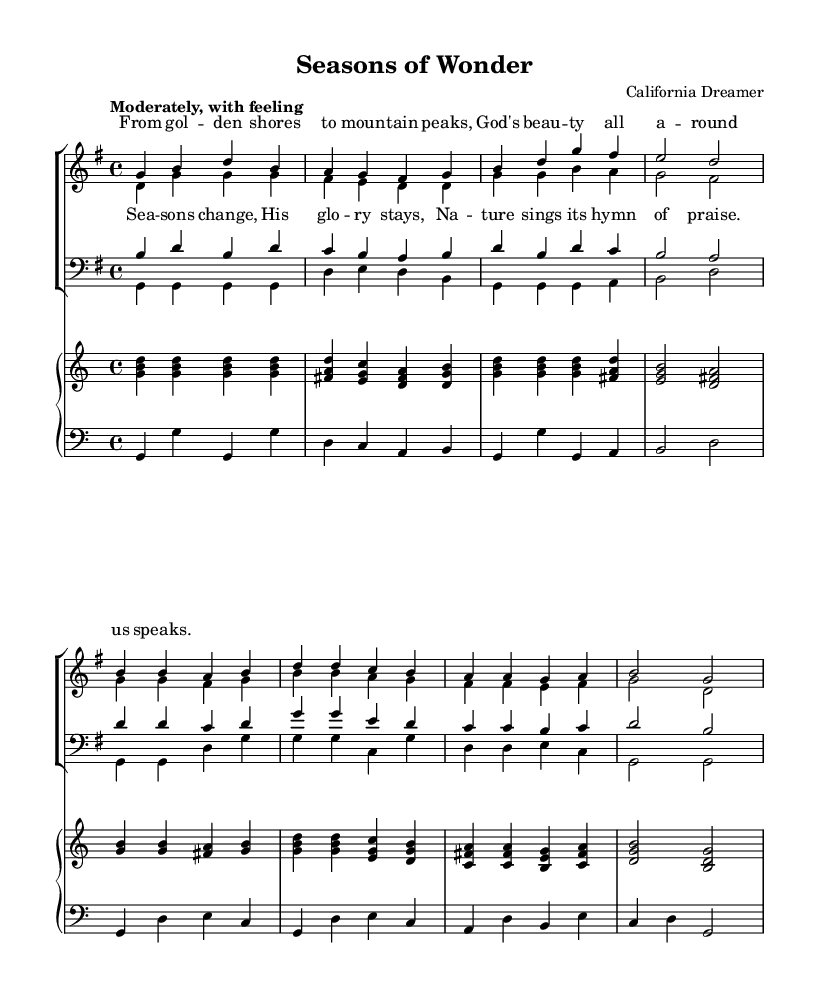What is the key signature of this music? The key signature is G major, which has one sharp (F#). This can be identified by the key signature notation at the beginning of the staff.
Answer: G major What is the time signature of this music? The time signature is 4/4, indicated by the fraction at the beginning of the piece. This means there are four beats in every measure and the quarter note gets one beat.
Answer: 4/4 What is the tempo marking for this piece? The tempo marking is "Moderately, with feeling," which indicates the speed and expression intended by the composer. It reflects a moderate pace.
Answer: Moderately, with feeling How many verses are set to music in this piece? There are two verses presented in the score, one for the soprano/alto part and another for the tenor/bass part. Each section is structured with similar musical phrases, indicating the format of verses.
Answer: Two verses What lyrical theme does the chorus emphasize? The chorus lyrics emphasize the permanence of God’s glory in nature, which sings praise regardless of changing seasons. This is deduced from the lyrics that mention "Seasons change, His glory stays."
Answer: God's glory What vocal parts are included in this choir arrangement? The vocal parts included are soprano, alto, tenor, and bass, as indicated by the different voices specified for the choir. This arrangement allows for harmony across different registers.
Answer: Soprano, alto, tenor, bass What is the overall title of this piece? The title of the piece is "Seasons of Wonder," as noted in the header at the beginning of the score. This title reflects the theme of nature and the changing seasons discussed in the music.
Answer: Seasons of Wonder 